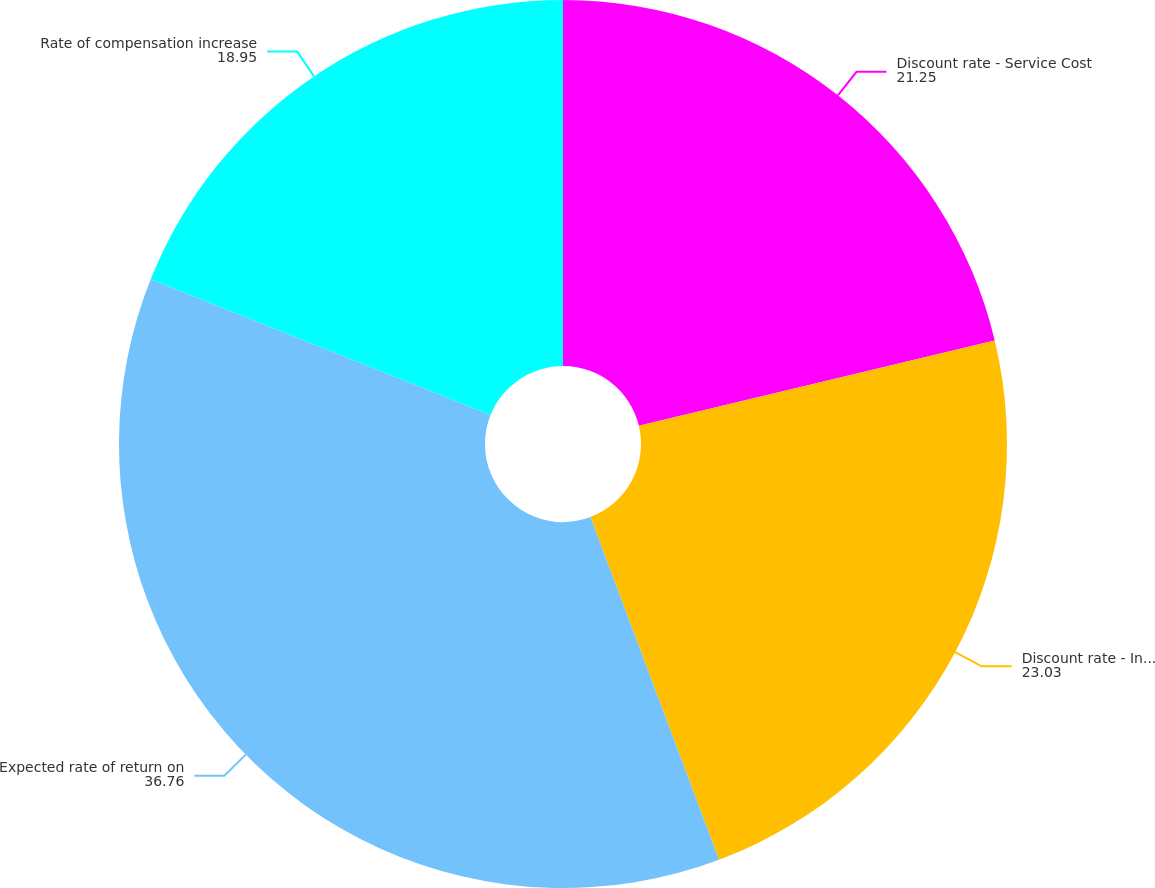Convert chart to OTSL. <chart><loc_0><loc_0><loc_500><loc_500><pie_chart><fcel>Discount rate - Service Cost<fcel>Discount rate - Interest Cost<fcel>Expected rate of return on<fcel>Rate of compensation increase<nl><fcel>21.25%<fcel>23.03%<fcel>36.76%<fcel>18.95%<nl></chart> 